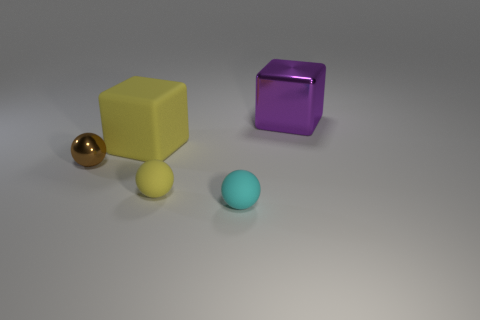Add 3 purple metallic blocks. How many objects exist? 8 Subtract all spheres. How many objects are left? 2 Subtract all tiny blue objects. Subtract all cyan rubber spheres. How many objects are left? 4 Add 2 big blocks. How many big blocks are left? 4 Add 2 large brown metallic objects. How many large brown metallic objects exist? 2 Subtract 0 green blocks. How many objects are left? 5 